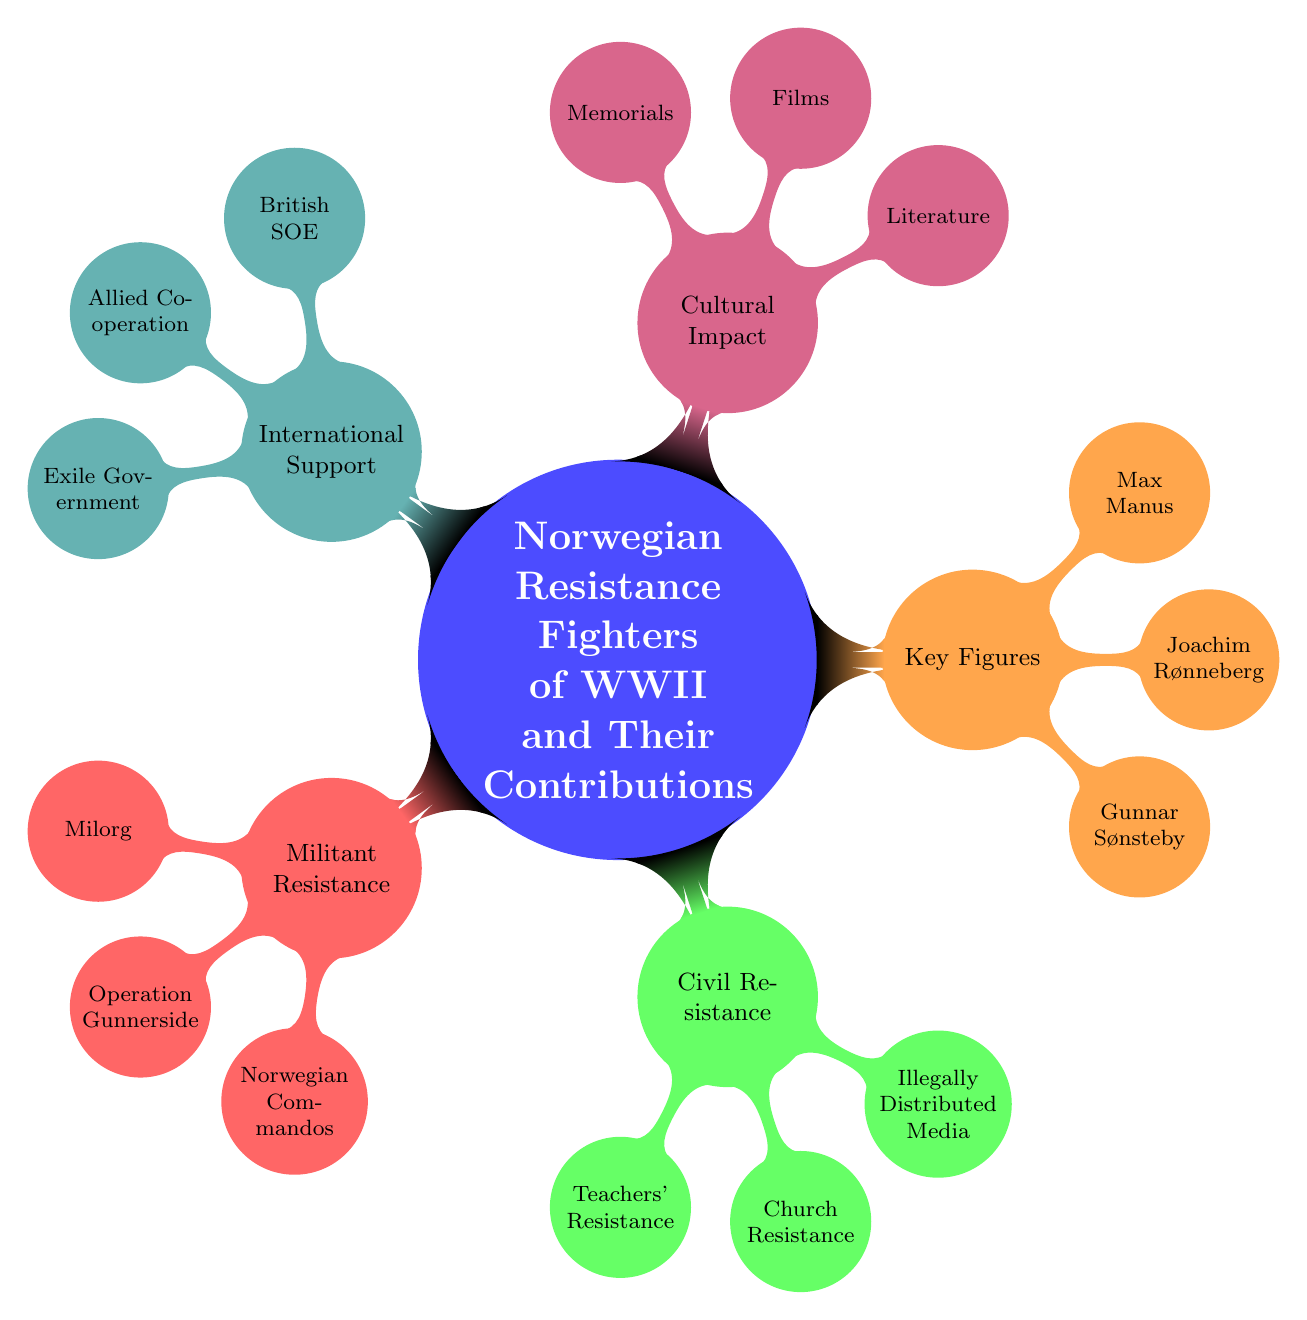What is the main topic of the mind map? The central node of the mind map clearly states "Norwegian Resistance Fighters of WWII and Their Contributions" as the main topic.
Answer: Norwegian Resistance Fighters of WWII and Their Contributions How many subtopics are there in the mind map? Counting the branches directly from the main topic, there are a total of five subtopics: Militant Resistance, Civil Resistance, Key Figures, Cultural Impact, and International Support.
Answer: 5 What is the first branch listed under Militant Resistance? Looking under the Militant Resistance section, the first branch listed is "Milorg."
Answer: Milorg Which key figure is associated with Operation Gunnerside? In the Key Figures section, "Joachim Rønneberg" is indicated as the leader associated with Operation Gunnerside.
Answer: Joachim Rønneberg What resistance group organized sabotage operations? The node under Militant Resistance titled "Milorg" indicates that it is the key resistance group that organized sabotage and intelligence operations.
Answer: Milorg How did the Norwegian Church contribute to civil resistance? Under the Civil Resistance section, the branch labeled "Church Resistance" explains that the Norwegian Church resisted Nazi ideology, playing a role in maintaining national morale.
Answer: Resisted Nazi ideology What medium did the underground use to spread information? In the Civil Resistance section, the branch titled "Illegally Distributed Media" specifies that underground newspapers and leaflets were used to spread information and bolster morale.
Answer: Underground newspapers and leaflets What kind of support did the British SOE provide? The British SOE is mentioned in the International Support section, indicating it trained and supported Norwegian resistance fighters.
Answer: Training and support Which cultural impact involves monuments dedicated to the resistance fighters? The branch named "Memorials" under the Cultural Impact section refers to monuments and museums dedicated to the bravery and sacrifices of resistance fighters.
Answer: Memorials 